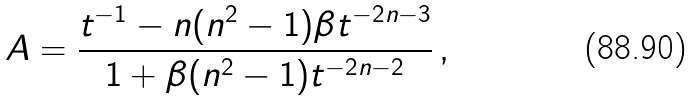<formula> <loc_0><loc_0><loc_500><loc_500>A = \frac { t ^ { - 1 } - n ( n ^ { 2 } - 1 ) \beta t ^ { - 2 n - 3 } } { 1 + \beta ( n ^ { 2 } - 1 ) t ^ { - 2 n - 2 } } \, ,</formula> 